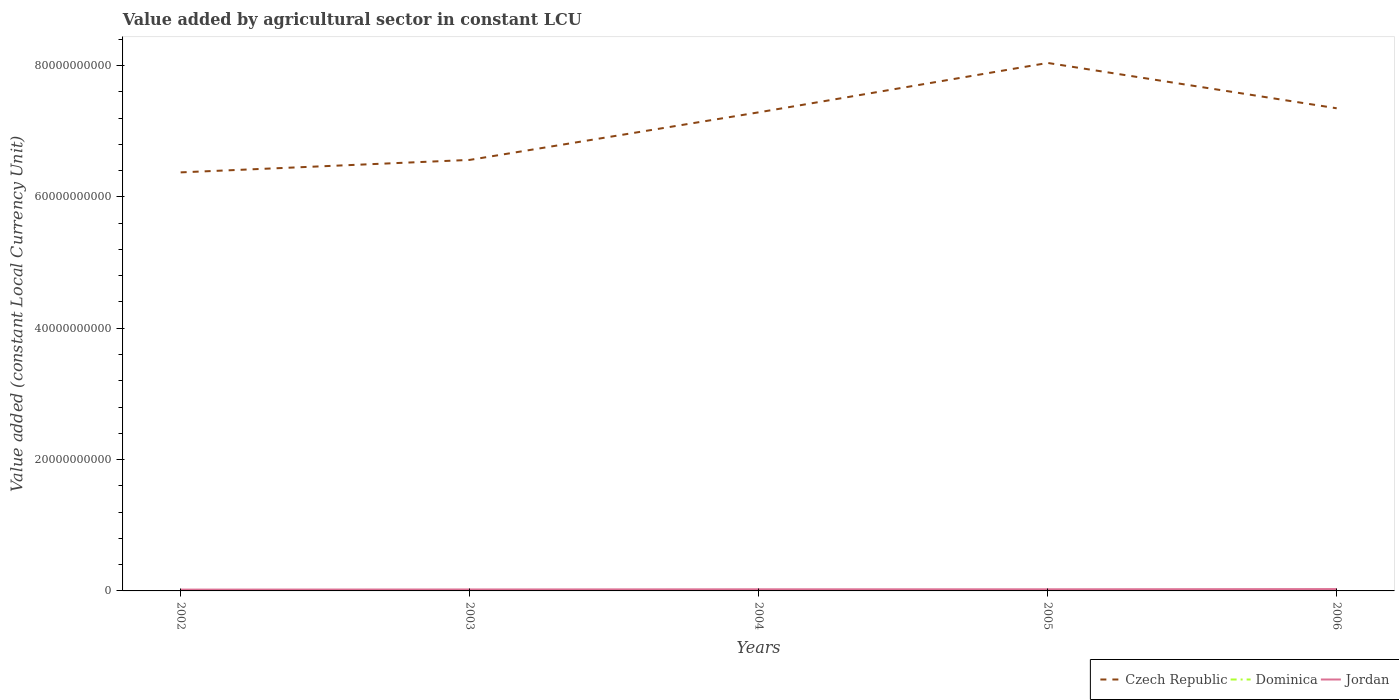How many different coloured lines are there?
Offer a terse response. 3. Does the line corresponding to Czech Republic intersect with the line corresponding to Jordan?
Make the answer very short. No. Is the number of lines equal to the number of legend labels?
Provide a short and direct response. Yes. Across all years, what is the maximum value added by agricultural sector in Czech Republic?
Keep it short and to the point. 6.37e+1. What is the total value added by agricultural sector in Dominica in the graph?
Your response must be concise. 6.88e+05. What is the difference between the highest and the second highest value added by agricultural sector in Dominica?
Your answer should be compact. 6.56e+06. What is the difference between the highest and the lowest value added by agricultural sector in Jordan?
Ensure brevity in your answer.  3. Are the values on the major ticks of Y-axis written in scientific E-notation?
Your answer should be compact. No. Does the graph contain any zero values?
Ensure brevity in your answer.  No. Where does the legend appear in the graph?
Your answer should be very brief. Bottom right. How are the legend labels stacked?
Keep it short and to the point. Horizontal. What is the title of the graph?
Make the answer very short. Value added by agricultural sector in constant LCU. What is the label or title of the X-axis?
Offer a terse response. Years. What is the label or title of the Y-axis?
Provide a succinct answer. Value added (constant Local Currency Unit). What is the Value added (constant Local Currency Unit) of Czech Republic in 2002?
Keep it short and to the point. 6.37e+1. What is the Value added (constant Local Currency Unit) of Dominica in 2002?
Make the answer very short. 1.16e+08. What is the Value added (constant Local Currency Unit) in Jordan in 2002?
Make the answer very short. 1.99e+08. What is the Value added (constant Local Currency Unit) in Czech Republic in 2003?
Your answer should be very brief. 6.56e+1. What is the Value added (constant Local Currency Unit) of Dominica in 2003?
Your response must be concise. 1.10e+08. What is the Value added (constant Local Currency Unit) of Jordan in 2003?
Your answer should be very brief. 2.22e+08. What is the Value added (constant Local Currency Unit) in Czech Republic in 2004?
Provide a short and direct response. 7.29e+1. What is the Value added (constant Local Currency Unit) of Dominica in 2004?
Make the answer very short. 1.10e+08. What is the Value added (constant Local Currency Unit) of Jordan in 2004?
Your response must be concise. 2.47e+08. What is the Value added (constant Local Currency Unit) of Czech Republic in 2005?
Your answer should be very brief. 8.04e+1. What is the Value added (constant Local Currency Unit) in Dominica in 2005?
Offer a very short reply. 1.09e+08. What is the Value added (constant Local Currency Unit) of Jordan in 2005?
Your response must be concise. 2.48e+08. What is the Value added (constant Local Currency Unit) in Czech Republic in 2006?
Give a very brief answer. 7.35e+1. What is the Value added (constant Local Currency Unit) in Dominica in 2006?
Provide a succinct answer. 1.11e+08. What is the Value added (constant Local Currency Unit) of Jordan in 2006?
Provide a succinct answer. 2.80e+08. Across all years, what is the maximum Value added (constant Local Currency Unit) in Czech Republic?
Keep it short and to the point. 8.04e+1. Across all years, what is the maximum Value added (constant Local Currency Unit) of Dominica?
Ensure brevity in your answer.  1.16e+08. Across all years, what is the maximum Value added (constant Local Currency Unit) in Jordan?
Keep it short and to the point. 2.80e+08. Across all years, what is the minimum Value added (constant Local Currency Unit) in Czech Republic?
Your response must be concise. 6.37e+1. Across all years, what is the minimum Value added (constant Local Currency Unit) in Dominica?
Ensure brevity in your answer.  1.09e+08. Across all years, what is the minimum Value added (constant Local Currency Unit) of Jordan?
Offer a very short reply. 1.99e+08. What is the total Value added (constant Local Currency Unit) of Czech Republic in the graph?
Offer a terse response. 3.56e+11. What is the total Value added (constant Local Currency Unit) of Dominica in the graph?
Your response must be concise. 5.54e+08. What is the total Value added (constant Local Currency Unit) of Jordan in the graph?
Offer a very short reply. 1.20e+09. What is the difference between the Value added (constant Local Currency Unit) of Czech Republic in 2002 and that in 2003?
Make the answer very short. -1.90e+09. What is the difference between the Value added (constant Local Currency Unit) of Dominica in 2002 and that in 2003?
Your answer should be compact. 5.99e+06. What is the difference between the Value added (constant Local Currency Unit) of Jordan in 2002 and that in 2003?
Offer a very short reply. -2.34e+07. What is the difference between the Value added (constant Local Currency Unit) of Czech Republic in 2002 and that in 2004?
Make the answer very short. -9.14e+09. What is the difference between the Value added (constant Local Currency Unit) in Dominica in 2002 and that in 2004?
Your answer should be very brief. 5.87e+06. What is the difference between the Value added (constant Local Currency Unit) of Jordan in 2002 and that in 2004?
Provide a succinct answer. -4.82e+07. What is the difference between the Value added (constant Local Currency Unit) of Czech Republic in 2002 and that in 2005?
Make the answer very short. -1.67e+1. What is the difference between the Value added (constant Local Currency Unit) in Dominica in 2002 and that in 2005?
Offer a very short reply. 6.56e+06. What is the difference between the Value added (constant Local Currency Unit) of Jordan in 2002 and that in 2005?
Provide a succinct answer. -4.89e+07. What is the difference between the Value added (constant Local Currency Unit) in Czech Republic in 2002 and that in 2006?
Give a very brief answer. -9.76e+09. What is the difference between the Value added (constant Local Currency Unit) of Dominica in 2002 and that in 2006?
Your answer should be compact. 4.91e+06. What is the difference between the Value added (constant Local Currency Unit) of Jordan in 2002 and that in 2006?
Give a very brief answer. -8.12e+07. What is the difference between the Value added (constant Local Currency Unit) in Czech Republic in 2003 and that in 2004?
Keep it short and to the point. -7.24e+09. What is the difference between the Value added (constant Local Currency Unit) in Dominica in 2003 and that in 2004?
Offer a terse response. -1.18e+05. What is the difference between the Value added (constant Local Currency Unit) of Jordan in 2003 and that in 2004?
Provide a succinct answer. -2.48e+07. What is the difference between the Value added (constant Local Currency Unit) in Czech Republic in 2003 and that in 2005?
Your answer should be compact. -1.48e+1. What is the difference between the Value added (constant Local Currency Unit) in Dominica in 2003 and that in 2005?
Ensure brevity in your answer.  5.70e+05. What is the difference between the Value added (constant Local Currency Unit) in Jordan in 2003 and that in 2005?
Keep it short and to the point. -2.55e+07. What is the difference between the Value added (constant Local Currency Unit) in Czech Republic in 2003 and that in 2006?
Your response must be concise. -7.86e+09. What is the difference between the Value added (constant Local Currency Unit) in Dominica in 2003 and that in 2006?
Keep it short and to the point. -1.08e+06. What is the difference between the Value added (constant Local Currency Unit) in Jordan in 2003 and that in 2006?
Make the answer very short. -5.79e+07. What is the difference between the Value added (constant Local Currency Unit) of Czech Republic in 2004 and that in 2005?
Offer a terse response. -7.52e+09. What is the difference between the Value added (constant Local Currency Unit) of Dominica in 2004 and that in 2005?
Your answer should be very brief. 6.88e+05. What is the difference between the Value added (constant Local Currency Unit) in Jordan in 2004 and that in 2005?
Your response must be concise. -6.73e+05. What is the difference between the Value added (constant Local Currency Unit) in Czech Republic in 2004 and that in 2006?
Offer a terse response. -6.16e+08. What is the difference between the Value added (constant Local Currency Unit) of Dominica in 2004 and that in 2006?
Give a very brief answer. -9.59e+05. What is the difference between the Value added (constant Local Currency Unit) of Jordan in 2004 and that in 2006?
Your response must be concise. -3.30e+07. What is the difference between the Value added (constant Local Currency Unit) of Czech Republic in 2005 and that in 2006?
Your answer should be very brief. 6.90e+09. What is the difference between the Value added (constant Local Currency Unit) of Dominica in 2005 and that in 2006?
Make the answer very short. -1.65e+06. What is the difference between the Value added (constant Local Currency Unit) in Jordan in 2005 and that in 2006?
Your answer should be compact. -3.24e+07. What is the difference between the Value added (constant Local Currency Unit) of Czech Republic in 2002 and the Value added (constant Local Currency Unit) of Dominica in 2003?
Ensure brevity in your answer.  6.36e+1. What is the difference between the Value added (constant Local Currency Unit) in Czech Republic in 2002 and the Value added (constant Local Currency Unit) in Jordan in 2003?
Provide a succinct answer. 6.35e+1. What is the difference between the Value added (constant Local Currency Unit) of Dominica in 2002 and the Value added (constant Local Currency Unit) of Jordan in 2003?
Provide a short and direct response. -1.06e+08. What is the difference between the Value added (constant Local Currency Unit) in Czech Republic in 2002 and the Value added (constant Local Currency Unit) in Dominica in 2004?
Offer a very short reply. 6.36e+1. What is the difference between the Value added (constant Local Currency Unit) of Czech Republic in 2002 and the Value added (constant Local Currency Unit) of Jordan in 2004?
Make the answer very short. 6.35e+1. What is the difference between the Value added (constant Local Currency Unit) in Dominica in 2002 and the Value added (constant Local Currency Unit) in Jordan in 2004?
Ensure brevity in your answer.  -1.31e+08. What is the difference between the Value added (constant Local Currency Unit) in Czech Republic in 2002 and the Value added (constant Local Currency Unit) in Dominica in 2005?
Provide a short and direct response. 6.36e+1. What is the difference between the Value added (constant Local Currency Unit) of Czech Republic in 2002 and the Value added (constant Local Currency Unit) of Jordan in 2005?
Your answer should be very brief. 6.35e+1. What is the difference between the Value added (constant Local Currency Unit) of Dominica in 2002 and the Value added (constant Local Currency Unit) of Jordan in 2005?
Keep it short and to the point. -1.32e+08. What is the difference between the Value added (constant Local Currency Unit) in Czech Republic in 2002 and the Value added (constant Local Currency Unit) in Dominica in 2006?
Offer a terse response. 6.36e+1. What is the difference between the Value added (constant Local Currency Unit) in Czech Republic in 2002 and the Value added (constant Local Currency Unit) in Jordan in 2006?
Make the answer very short. 6.34e+1. What is the difference between the Value added (constant Local Currency Unit) in Dominica in 2002 and the Value added (constant Local Currency Unit) in Jordan in 2006?
Your answer should be compact. -1.64e+08. What is the difference between the Value added (constant Local Currency Unit) of Czech Republic in 2003 and the Value added (constant Local Currency Unit) of Dominica in 2004?
Provide a succinct answer. 6.55e+1. What is the difference between the Value added (constant Local Currency Unit) of Czech Republic in 2003 and the Value added (constant Local Currency Unit) of Jordan in 2004?
Make the answer very short. 6.54e+1. What is the difference between the Value added (constant Local Currency Unit) in Dominica in 2003 and the Value added (constant Local Currency Unit) in Jordan in 2004?
Offer a very short reply. -1.37e+08. What is the difference between the Value added (constant Local Currency Unit) of Czech Republic in 2003 and the Value added (constant Local Currency Unit) of Dominica in 2005?
Offer a very short reply. 6.55e+1. What is the difference between the Value added (constant Local Currency Unit) in Czech Republic in 2003 and the Value added (constant Local Currency Unit) in Jordan in 2005?
Offer a terse response. 6.54e+1. What is the difference between the Value added (constant Local Currency Unit) in Dominica in 2003 and the Value added (constant Local Currency Unit) in Jordan in 2005?
Your answer should be compact. -1.38e+08. What is the difference between the Value added (constant Local Currency Unit) of Czech Republic in 2003 and the Value added (constant Local Currency Unit) of Dominica in 2006?
Your response must be concise. 6.55e+1. What is the difference between the Value added (constant Local Currency Unit) in Czech Republic in 2003 and the Value added (constant Local Currency Unit) in Jordan in 2006?
Your response must be concise. 6.53e+1. What is the difference between the Value added (constant Local Currency Unit) of Dominica in 2003 and the Value added (constant Local Currency Unit) of Jordan in 2006?
Ensure brevity in your answer.  -1.70e+08. What is the difference between the Value added (constant Local Currency Unit) of Czech Republic in 2004 and the Value added (constant Local Currency Unit) of Dominica in 2005?
Give a very brief answer. 7.28e+1. What is the difference between the Value added (constant Local Currency Unit) of Czech Republic in 2004 and the Value added (constant Local Currency Unit) of Jordan in 2005?
Keep it short and to the point. 7.26e+1. What is the difference between the Value added (constant Local Currency Unit) in Dominica in 2004 and the Value added (constant Local Currency Unit) in Jordan in 2005?
Provide a short and direct response. -1.38e+08. What is the difference between the Value added (constant Local Currency Unit) of Czech Republic in 2004 and the Value added (constant Local Currency Unit) of Dominica in 2006?
Provide a succinct answer. 7.28e+1. What is the difference between the Value added (constant Local Currency Unit) in Czech Republic in 2004 and the Value added (constant Local Currency Unit) in Jordan in 2006?
Your answer should be compact. 7.26e+1. What is the difference between the Value added (constant Local Currency Unit) in Dominica in 2004 and the Value added (constant Local Currency Unit) in Jordan in 2006?
Ensure brevity in your answer.  -1.70e+08. What is the difference between the Value added (constant Local Currency Unit) of Czech Republic in 2005 and the Value added (constant Local Currency Unit) of Dominica in 2006?
Make the answer very short. 8.03e+1. What is the difference between the Value added (constant Local Currency Unit) of Czech Republic in 2005 and the Value added (constant Local Currency Unit) of Jordan in 2006?
Your answer should be very brief. 8.01e+1. What is the difference between the Value added (constant Local Currency Unit) in Dominica in 2005 and the Value added (constant Local Currency Unit) in Jordan in 2006?
Your response must be concise. -1.71e+08. What is the average Value added (constant Local Currency Unit) in Czech Republic per year?
Offer a terse response. 7.12e+1. What is the average Value added (constant Local Currency Unit) in Dominica per year?
Provide a short and direct response. 1.11e+08. What is the average Value added (constant Local Currency Unit) of Jordan per year?
Ensure brevity in your answer.  2.39e+08. In the year 2002, what is the difference between the Value added (constant Local Currency Unit) in Czech Republic and Value added (constant Local Currency Unit) in Dominica?
Offer a very short reply. 6.36e+1. In the year 2002, what is the difference between the Value added (constant Local Currency Unit) of Czech Republic and Value added (constant Local Currency Unit) of Jordan?
Keep it short and to the point. 6.35e+1. In the year 2002, what is the difference between the Value added (constant Local Currency Unit) in Dominica and Value added (constant Local Currency Unit) in Jordan?
Your answer should be compact. -8.31e+07. In the year 2003, what is the difference between the Value added (constant Local Currency Unit) of Czech Republic and Value added (constant Local Currency Unit) of Dominica?
Ensure brevity in your answer.  6.55e+1. In the year 2003, what is the difference between the Value added (constant Local Currency Unit) of Czech Republic and Value added (constant Local Currency Unit) of Jordan?
Offer a very short reply. 6.54e+1. In the year 2003, what is the difference between the Value added (constant Local Currency Unit) of Dominica and Value added (constant Local Currency Unit) of Jordan?
Ensure brevity in your answer.  -1.12e+08. In the year 2004, what is the difference between the Value added (constant Local Currency Unit) of Czech Republic and Value added (constant Local Currency Unit) of Dominica?
Your response must be concise. 7.28e+1. In the year 2004, what is the difference between the Value added (constant Local Currency Unit) of Czech Republic and Value added (constant Local Currency Unit) of Jordan?
Keep it short and to the point. 7.26e+1. In the year 2004, what is the difference between the Value added (constant Local Currency Unit) of Dominica and Value added (constant Local Currency Unit) of Jordan?
Ensure brevity in your answer.  -1.37e+08. In the year 2005, what is the difference between the Value added (constant Local Currency Unit) of Czech Republic and Value added (constant Local Currency Unit) of Dominica?
Offer a terse response. 8.03e+1. In the year 2005, what is the difference between the Value added (constant Local Currency Unit) of Czech Republic and Value added (constant Local Currency Unit) of Jordan?
Provide a succinct answer. 8.01e+1. In the year 2005, what is the difference between the Value added (constant Local Currency Unit) in Dominica and Value added (constant Local Currency Unit) in Jordan?
Provide a succinct answer. -1.39e+08. In the year 2006, what is the difference between the Value added (constant Local Currency Unit) of Czech Republic and Value added (constant Local Currency Unit) of Dominica?
Your answer should be compact. 7.34e+1. In the year 2006, what is the difference between the Value added (constant Local Currency Unit) in Czech Republic and Value added (constant Local Currency Unit) in Jordan?
Your answer should be very brief. 7.32e+1. In the year 2006, what is the difference between the Value added (constant Local Currency Unit) in Dominica and Value added (constant Local Currency Unit) in Jordan?
Your answer should be compact. -1.69e+08. What is the ratio of the Value added (constant Local Currency Unit) in Czech Republic in 2002 to that in 2003?
Keep it short and to the point. 0.97. What is the ratio of the Value added (constant Local Currency Unit) of Dominica in 2002 to that in 2003?
Provide a succinct answer. 1.05. What is the ratio of the Value added (constant Local Currency Unit) of Jordan in 2002 to that in 2003?
Give a very brief answer. 0.89. What is the ratio of the Value added (constant Local Currency Unit) of Czech Republic in 2002 to that in 2004?
Provide a short and direct response. 0.87. What is the ratio of the Value added (constant Local Currency Unit) in Dominica in 2002 to that in 2004?
Ensure brevity in your answer.  1.05. What is the ratio of the Value added (constant Local Currency Unit) in Jordan in 2002 to that in 2004?
Give a very brief answer. 0.8. What is the ratio of the Value added (constant Local Currency Unit) in Czech Republic in 2002 to that in 2005?
Provide a short and direct response. 0.79. What is the ratio of the Value added (constant Local Currency Unit) of Dominica in 2002 to that in 2005?
Ensure brevity in your answer.  1.06. What is the ratio of the Value added (constant Local Currency Unit) in Jordan in 2002 to that in 2005?
Your response must be concise. 0.8. What is the ratio of the Value added (constant Local Currency Unit) of Czech Republic in 2002 to that in 2006?
Offer a terse response. 0.87. What is the ratio of the Value added (constant Local Currency Unit) of Dominica in 2002 to that in 2006?
Give a very brief answer. 1.04. What is the ratio of the Value added (constant Local Currency Unit) in Jordan in 2002 to that in 2006?
Keep it short and to the point. 0.71. What is the ratio of the Value added (constant Local Currency Unit) of Czech Republic in 2003 to that in 2004?
Keep it short and to the point. 0.9. What is the ratio of the Value added (constant Local Currency Unit) in Dominica in 2003 to that in 2004?
Provide a short and direct response. 1. What is the ratio of the Value added (constant Local Currency Unit) of Jordan in 2003 to that in 2004?
Keep it short and to the point. 0.9. What is the ratio of the Value added (constant Local Currency Unit) in Czech Republic in 2003 to that in 2005?
Offer a terse response. 0.82. What is the ratio of the Value added (constant Local Currency Unit) of Dominica in 2003 to that in 2005?
Keep it short and to the point. 1.01. What is the ratio of the Value added (constant Local Currency Unit) of Jordan in 2003 to that in 2005?
Your answer should be compact. 0.9. What is the ratio of the Value added (constant Local Currency Unit) in Czech Republic in 2003 to that in 2006?
Your response must be concise. 0.89. What is the ratio of the Value added (constant Local Currency Unit) of Dominica in 2003 to that in 2006?
Your answer should be compact. 0.99. What is the ratio of the Value added (constant Local Currency Unit) of Jordan in 2003 to that in 2006?
Ensure brevity in your answer.  0.79. What is the ratio of the Value added (constant Local Currency Unit) in Czech Republic in 2004 to that in 2005?
Your answer should be compact. 0.91. What is the ratio of the Value added (constant Local Currency Unit) of Czech Republic in 2004 to that in 2006?
Your answer should be compact. 0.99. What is the ratio of the Value added (constant Local Currency Unit) in Dominica in 2004 to that in 2006?
Ensure brevity in your answer.  0.99. What is the ratio of the Value added (constant Local Currency Unit) of Jordan in 2004 to that in 2006?
Keep it short and to the point. 0.88. What is the ratio of the Value added (constant Local Currency Unit) in Czech Republic in 2005 to that in 2006?
Provide a succinct answer. 1.09. What is the ratio of the Value added (constant Local Currency Unit) of Dominica in 2005 to that in 2006?
Your answer should be compact. 0.99. What is the ratio of the Value added (constant Local Currency Unit) of Jordan in 2005 to that in 2006?
Keep it short and to the point. 0.88. What is the difference between the highest and the second highest Value added (constant Local Currency Unit) of Czech Republic?
Offer a terse response. 6.90e+09. What is the difference between the highest and the second highest Value added (constant Local Currency Unit) of Dominica?
Make the answer very short. 4.91e+06. What is the difference between the highest and the second highest Value added (constant Local Currency Unit) of Jordan?
Make the answer very short. 3.24e+07. What is the difference between the highest and the lowest Value added (constant Local Currency Unit) of Czech Republic?
Your response must be concise. 1.67e+1. What is the difference between the highest and the lowest Value added (constant Local Currency Unit) in Dominica?
Your answer should be compact. 6.56e+06. What is the difference between the highest and the lowest Value added (constant Local Currency Unit) of Jordan?
Make the answer very short. 8.12e+07. 